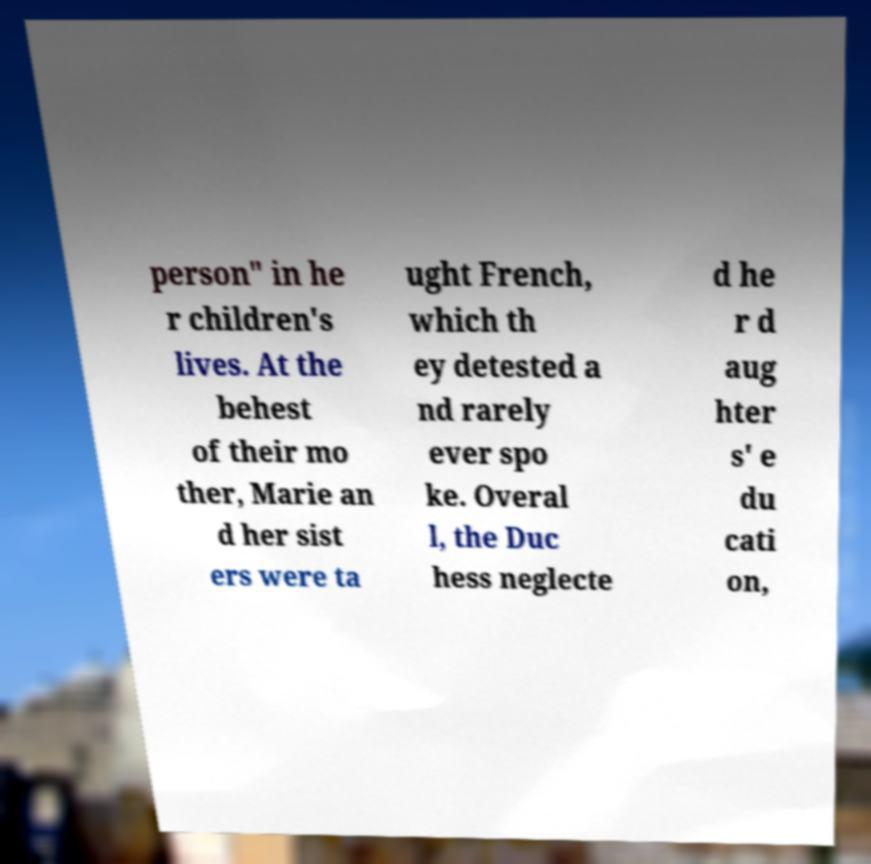Can you read and provide the text displayed in the image?This photo seems to have some interesting text. Can you extract and type it out for me? person" in he r children's lives. At the behest of their mo ther, Marie an d her sist ers were ta ught French, which th ey detested a nd rarely ever spo ke. Overal l, the Duc hess neglecte d he r d aug hter s' e du cati on, 